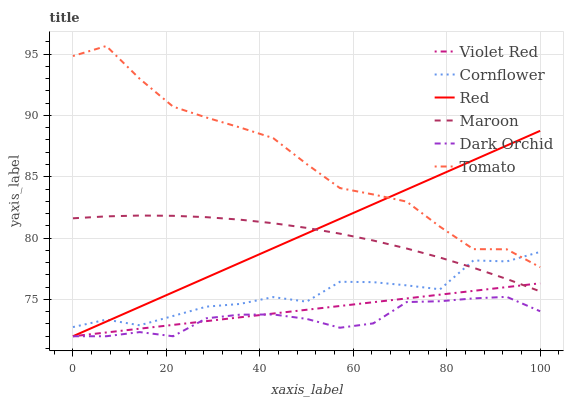Does Cornflower have the minimum area under the curve?
Answer yes or no. No. Does Cornflower have the maximum area under the curve?
Answer yes or no. No. Is Cornflower the smoothest?
Answer yes or no. No. Is Violet Red the roughest?
Answer yes or no. No. Does Cornflower have the lowest value?
Answer yes or no. No. Does Cornflower have the highest value?
Answer yes or no. No. Is Violet Red less than Tomato?
Answer yes or no. Yes. Is Tomato greater than Maroon?
Answer yes or no. Yes. Does Violet Red intersect Tomato?
Answer yes or no. No. 